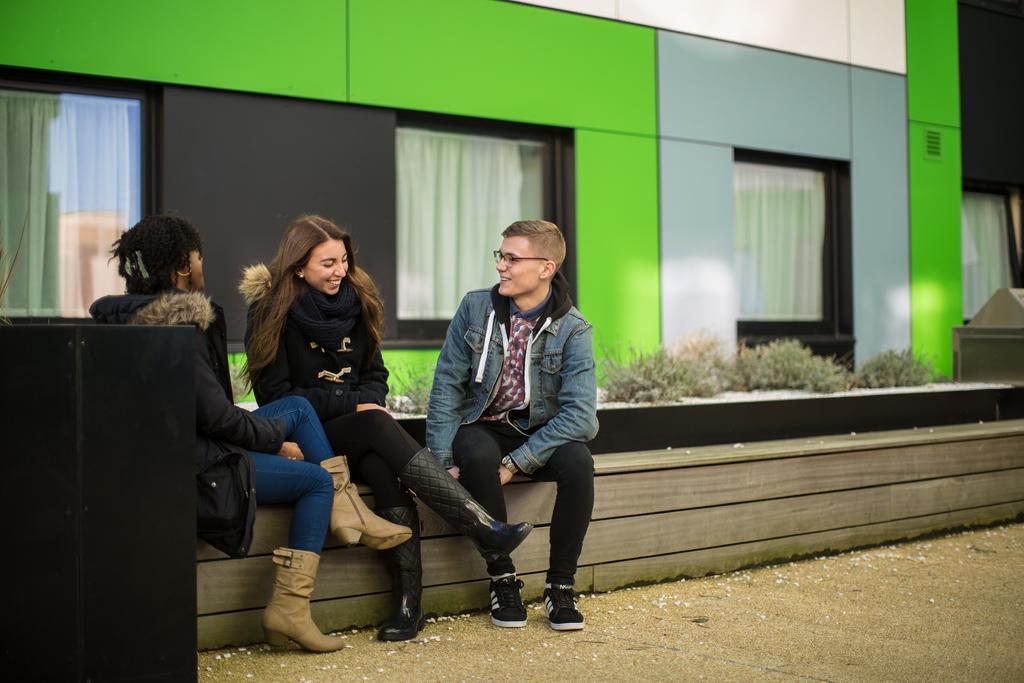Please provide a concise description of this image. In this image, we can see people wearing coats and one of them is wearing a scarf and are sitting on the bench. In the background, there is a building and we can see windows, through the glass we can see curtains and there is an object, which is in black color and there are some plants. At the bottom, there is a road. 